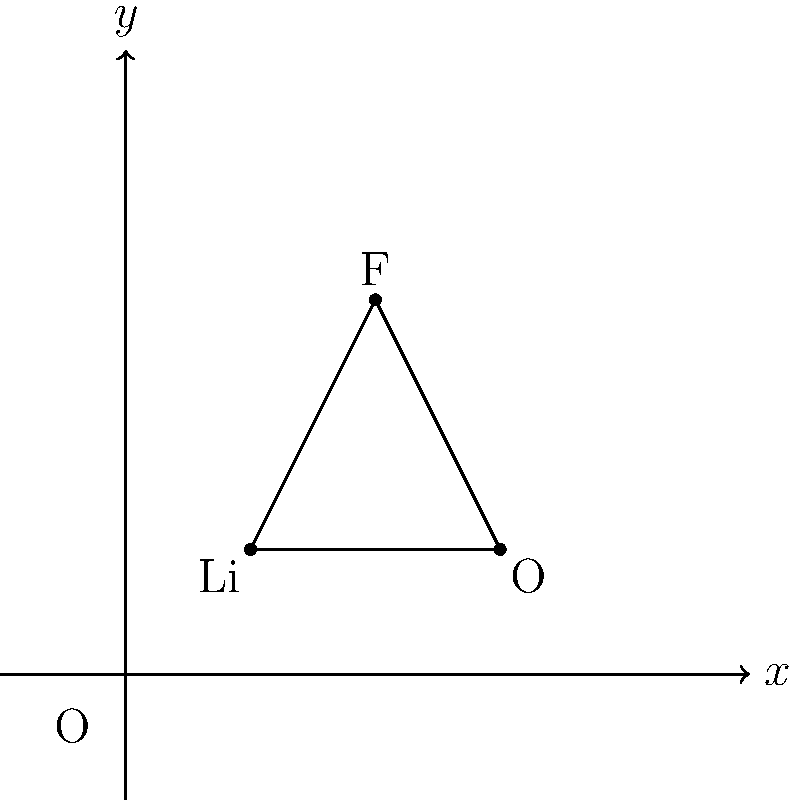The figure shows the molecular structure of a novel electrolyte compound for advanced lithium-ion batteries. Based on the structure, what is the molecular formula of this compound? To determine the molecular formula, we need to follow these steps:

1. Identify the elements present:
   - We can see Li (Lithium), O (Oxygen), and F (Fluorine)

2. Count the number of atoms for each element:
   - There is 1 Lithium atom
   - There is 1 Oxygen atom
   - There is 1 Fluorine atom

3. Write the molecular formula:
   - The molecular formula is written by listing the elements in order of electronegativity (usually starting with the metal if present) and using subscripts to indicate the number of atoms of each element.
   - In this case, we start with Li (the metal), followed by F (more electronegative than O), and then O.
   - Since there is only one atom of each element, no subscripts are needed.

Therefore, the molecular formula of this compound is LiFO.
Answer: LiFO 